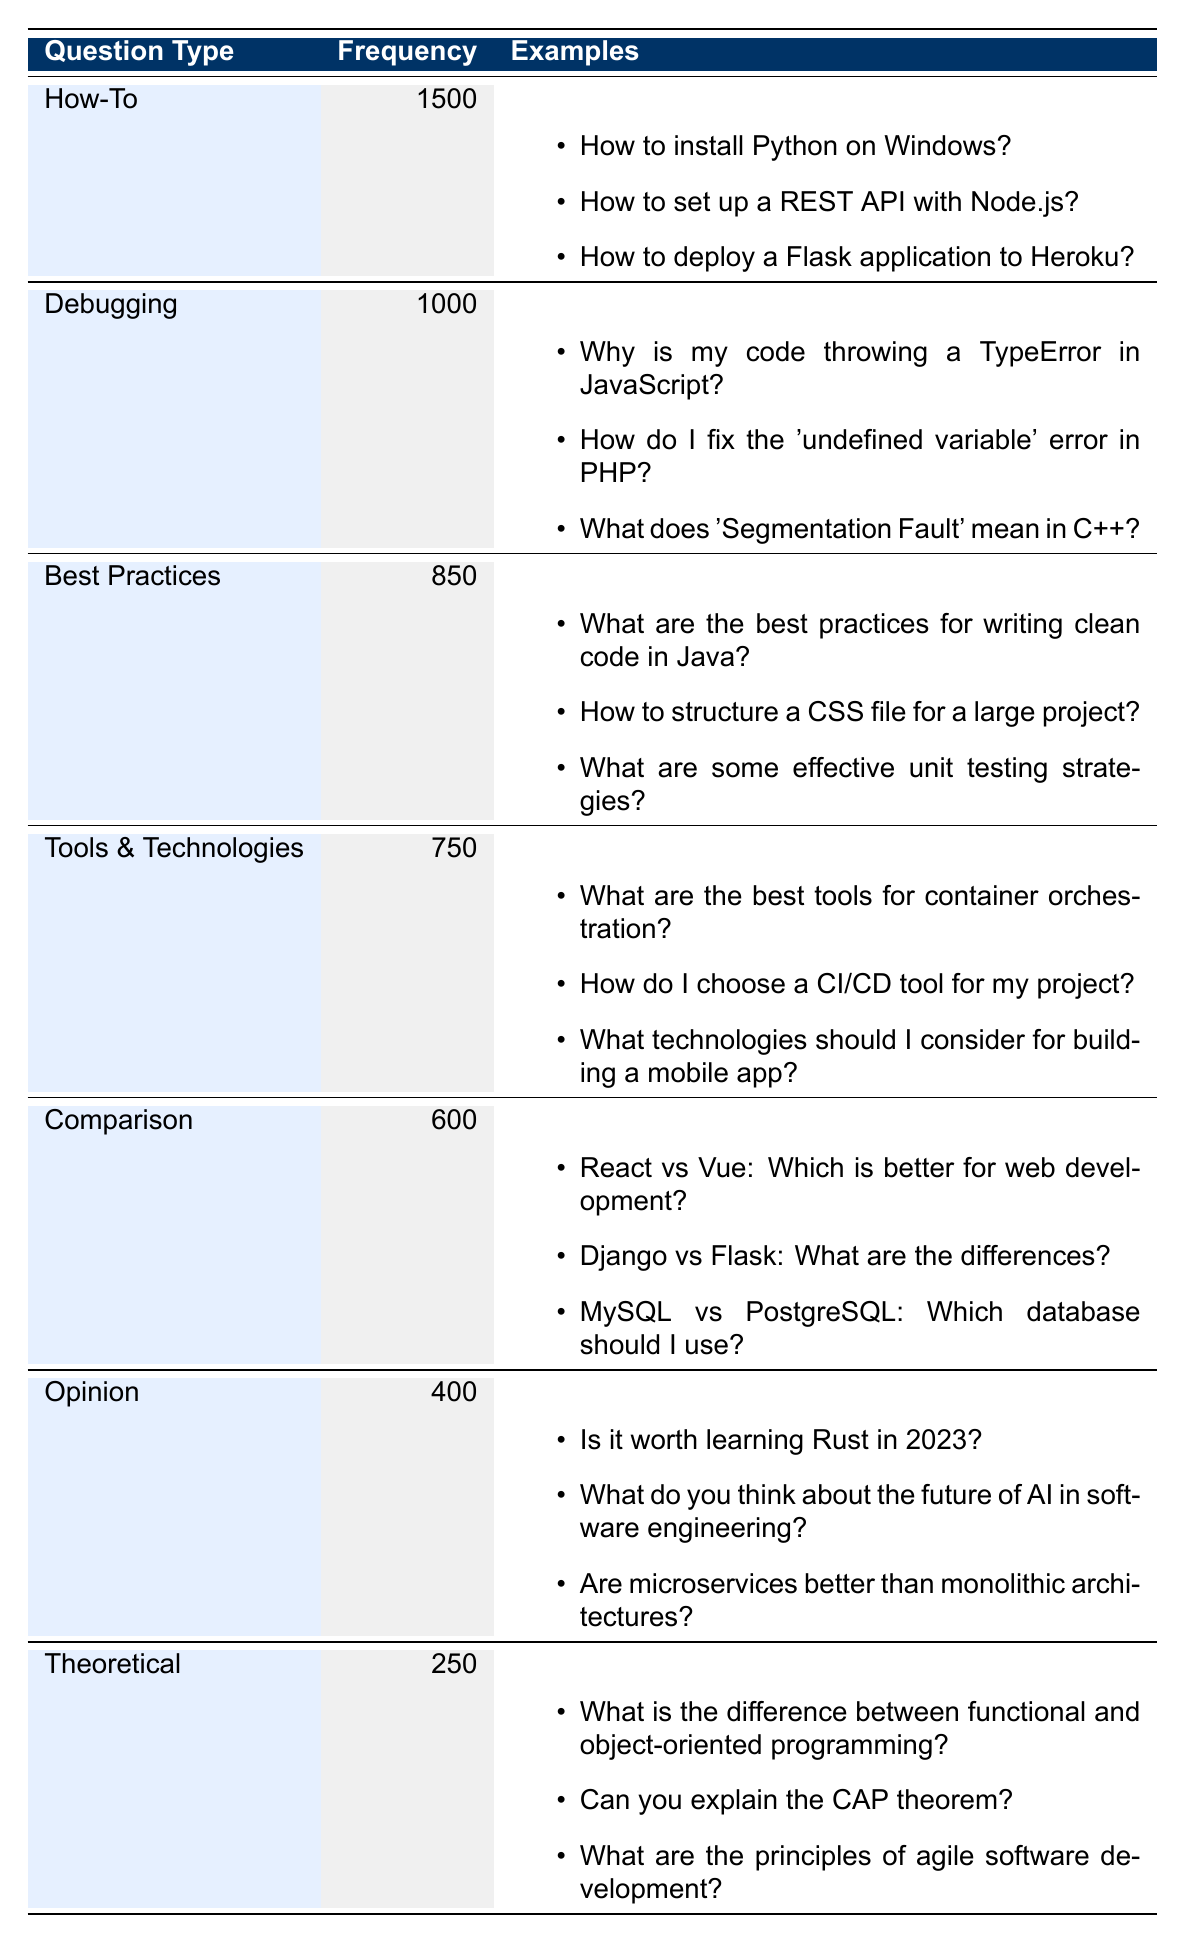What is the most frequently asked question type in the forum? According to the table, the question type with the highest frequency is "How-To," which has a frequency of 1500.
Answer: How-To How many total questions are categorized as "Debugging" and "Best Practices"? The table shows that "Debugging" has a frequency of 1000 and "Best Practices" has a frequency of 850. Adding these together gives 1000 + 850 = 1850.
Answer: 1850 Is the frequency of "Opinion" questions greater than that of "Theoretical" questions? The table indicates that "Opinion" has a frequency of 400, while "Theoretical" has a frequency of 250. Since 400 is greater than 250, the statement is true.
Answer: Yes What type of questions has a frequency of 750? By reviewing the table, we find that the "Tools & Technologies" category has a frequency of 750.
Answer: Tools & Technologies What is the average frequency of all question types listed in the table? To find the average, we first calculate the total frequency: 1500 + 1000 + 850 + 750 + 600 + 400 + 250 = 4350. There are 7 question types, so the average frequency is 4350 / 7, which equals approximately 621.43.
Answer: 621.43 Which question type has the lowest frequency? The table shows that "Theoretical" questions have the lowest frequency, which is 250.
Answer: Theoretical Is "Comparison" the second most common question type in the forum? Checking the frequency counts, "Debugging" has 1000, "Best Practices" has 850, and "Comparison" has 600. Therefore, it is not the second most common, as "Debugging" is.
Answer: No What is the difference in frequency between "How-To" and "Opinion"? From the table, "How-To" has 1500 and "Opinion" has 400. The difference is 1500 - 400 = 1100.
Answer: 1100 